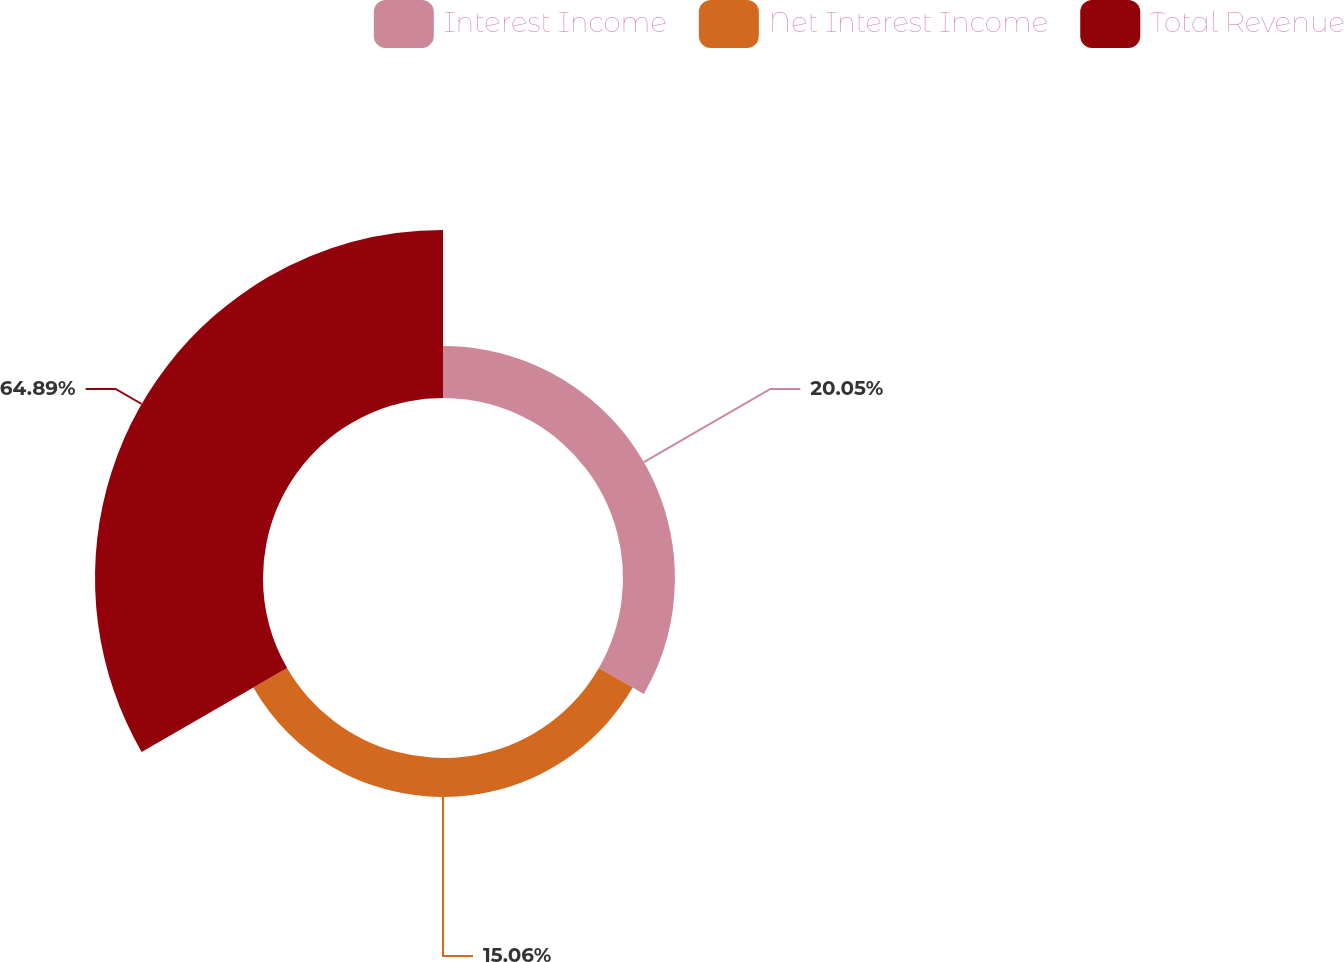Convert chart. <chart><loc_0><loc_0><loc_500><loc_500><pie_chart><fcel>Interest Income<fcel>Net Interest Income<fcel>Total Revenue<nl><fcel>20.05%<fcel>15.06%<fcel>64.89%<nl></chart> 